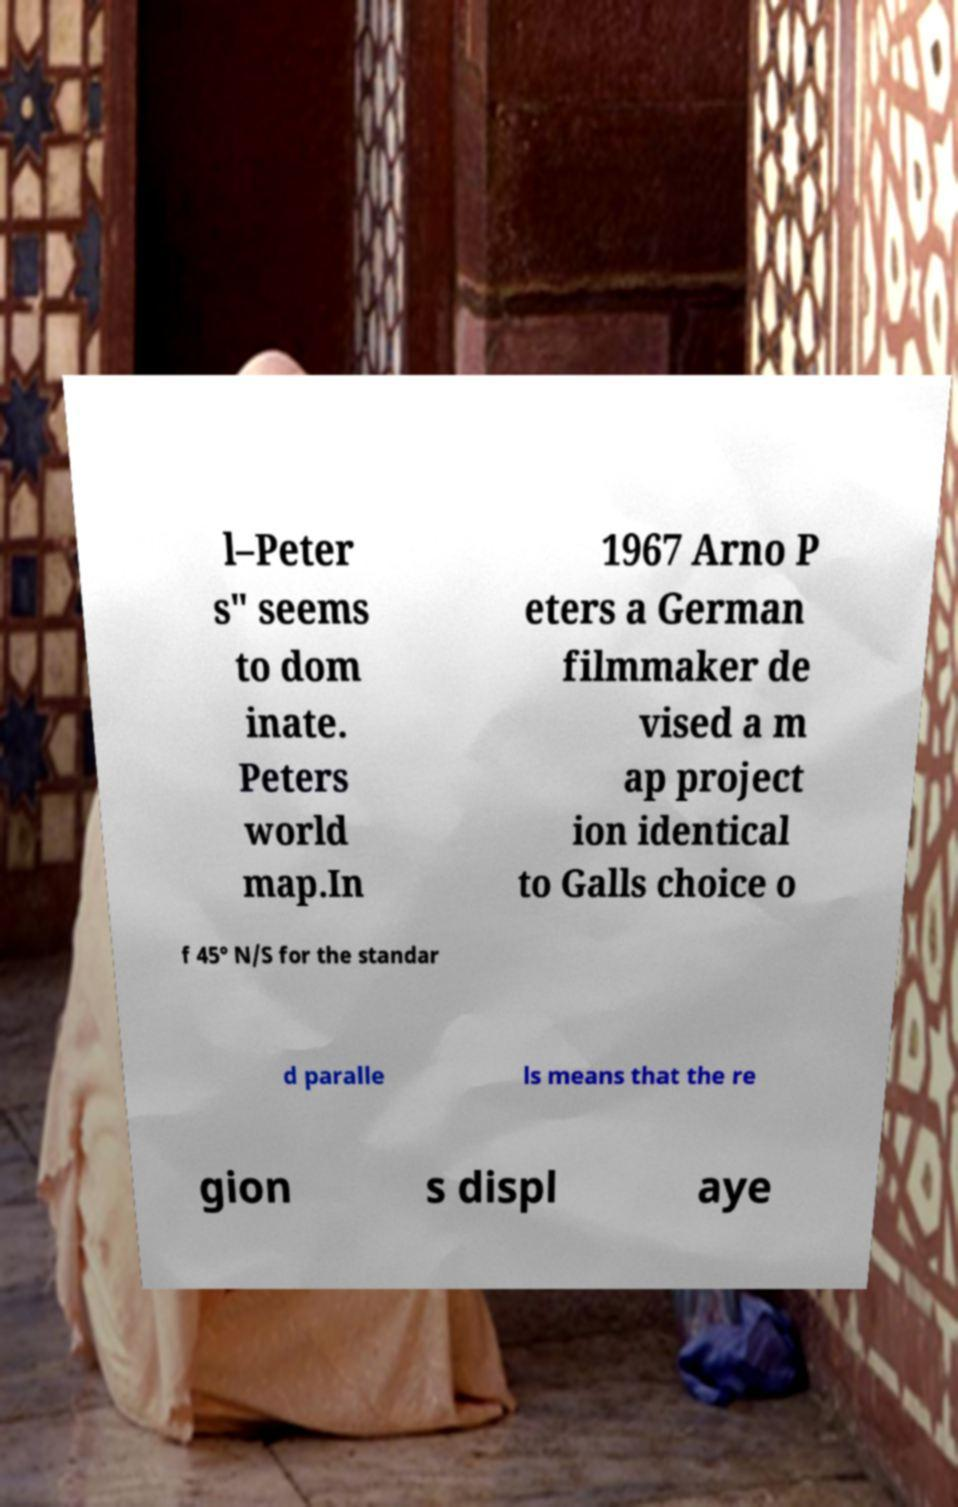Please identify and transcribe the text found in this image. l–Peter s" seems to dom inate. Peters world map.In 1967 Arno P eters a German filmmaker de vised a m ap project ion identical to Galls choice o f 45° N/S for the standar d paralle ls means that the re gion s displ aye 